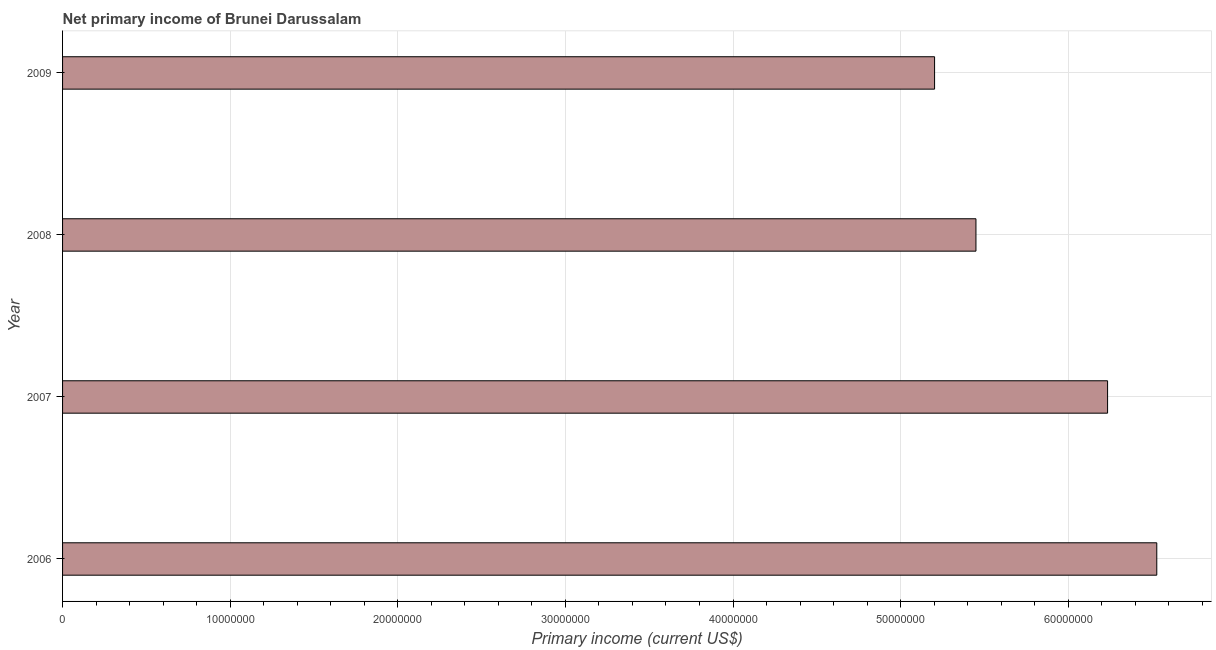Does the graph contain any zero values?
Ensure brevity in your answer.  No. Does the graph contain grids?
Provide a short and direct response. Yes. What is the title of the graph?
Offer a very short reply. Net primary income of Brunei Darussalam. What is the label or title of the X-axis?
Offer a terse response. Primary income (current US$). What is the amount of primary income in 2009?
Offer a terse response. 5.20e+07. Across all years, what is the maximum amount of primary income?
Ensure brevity in your answer.  6.53e+07. Across all years, what is the minimum amount of primary income?
Keep it short and to the point. 5.20e+07. What is the sum of the amount of primary income?
Ensure brevity in your answer.  2.34e+08. What is the difference between the amount of primary income in 2006 and 2007?
Keep it short and to the point. 2.94e+06. What is the average amount of primary income per year?
Keep it short and to the point. 5.85e+07. What is the median amount of primary income?
Offer a terse response. 5.84e+07. In how many years, is the amount of primary income greater than 28000000 US$?
Provide a short and direct response. 4. Do a majority of the years between 2009 and 2006 (inclusive) have amount of primary income greater than 12000000 US$?
Offer a very short reply. Yes. What is the ratio of the amount of primary income in 2006 to that in 2009?
Make the answer very short. 1.25. Is the difference between the amount of primary income in 2007 and 2009 greater than the difference between any two years?
Your answer should be very brief. No. What is the difference between the highest and the second highest amount of primary income?
Give a very brief answer. 2.94e+06. Is the sum of the amount of primary income in 2006 and 2007 greater than the maximum amount of primary income across all years?
Offer a very short reply. Yes. What is the difference between the highest and the lowest amount of primary income?
Ensure brevity in your answer.  1.33e+07. How many years are there in the graph?
Provide a succinct answer. 4. What is the Primary income (current US$) of 2006?
Keep it short and to the point. 6.53e+07. What is the Primary income (current US$) of 2007?
Keep it short and to the point. 6.23e+07. What is the Primary income (current US$) in 2008?
Ensure brevity in your answer.  5.45e+07. What is the Primary income (current US$) of 2009?
Keep it short and to the point. 5.20e+07. What is the difference between the Primary income (current US$) in 2006 and 2007?
Your answer should be very brief. 2.94e+06. What is the difference between the Primary income (current US$) in 2006 and 2008?
Your response must be concise. 1.08e+07. What is the difference between the Primary income (current US$) in 2006 and 2009?
Keep it short and to the point. 1.33e+07. What is the difference between the Primary income (current US$) in 2007 and 2008?
Offer a very short reply. 7.85e+06. What is the difference between the Primary income (current US$) in 2007 and 2009?
Provide a succinct answer. 1.03e+07. What is the difference between the Primary income (current US$) in 2008 and 2009?
Your response must be concise. 2.47e+06. What is the ratio of the Primary income (current US$) in 2006 to that in 2007?
Offer a very short reply. 1.05. What is the ratio of the Primary income (current US$) in 2006 to that in 2008?
Provide a short and direct response. 1.2. What is the ratio of the Primary income (current US$) in 2006 to that in 2009?
Ensure brevity in your answer.  1.25. What is the ratio of the Primary income (current US$) in 2007 to that in 2008?
Offer a very short reply. 1.14. What is the ratio of the Primary income (current US$) in 2007 to that in 2009?
Keep it short and to the point. 1.2. What is the ratio of the Primary income (current US$) in 2008 to that in 2009?
Ensure brevity in your answer.  1.05. 